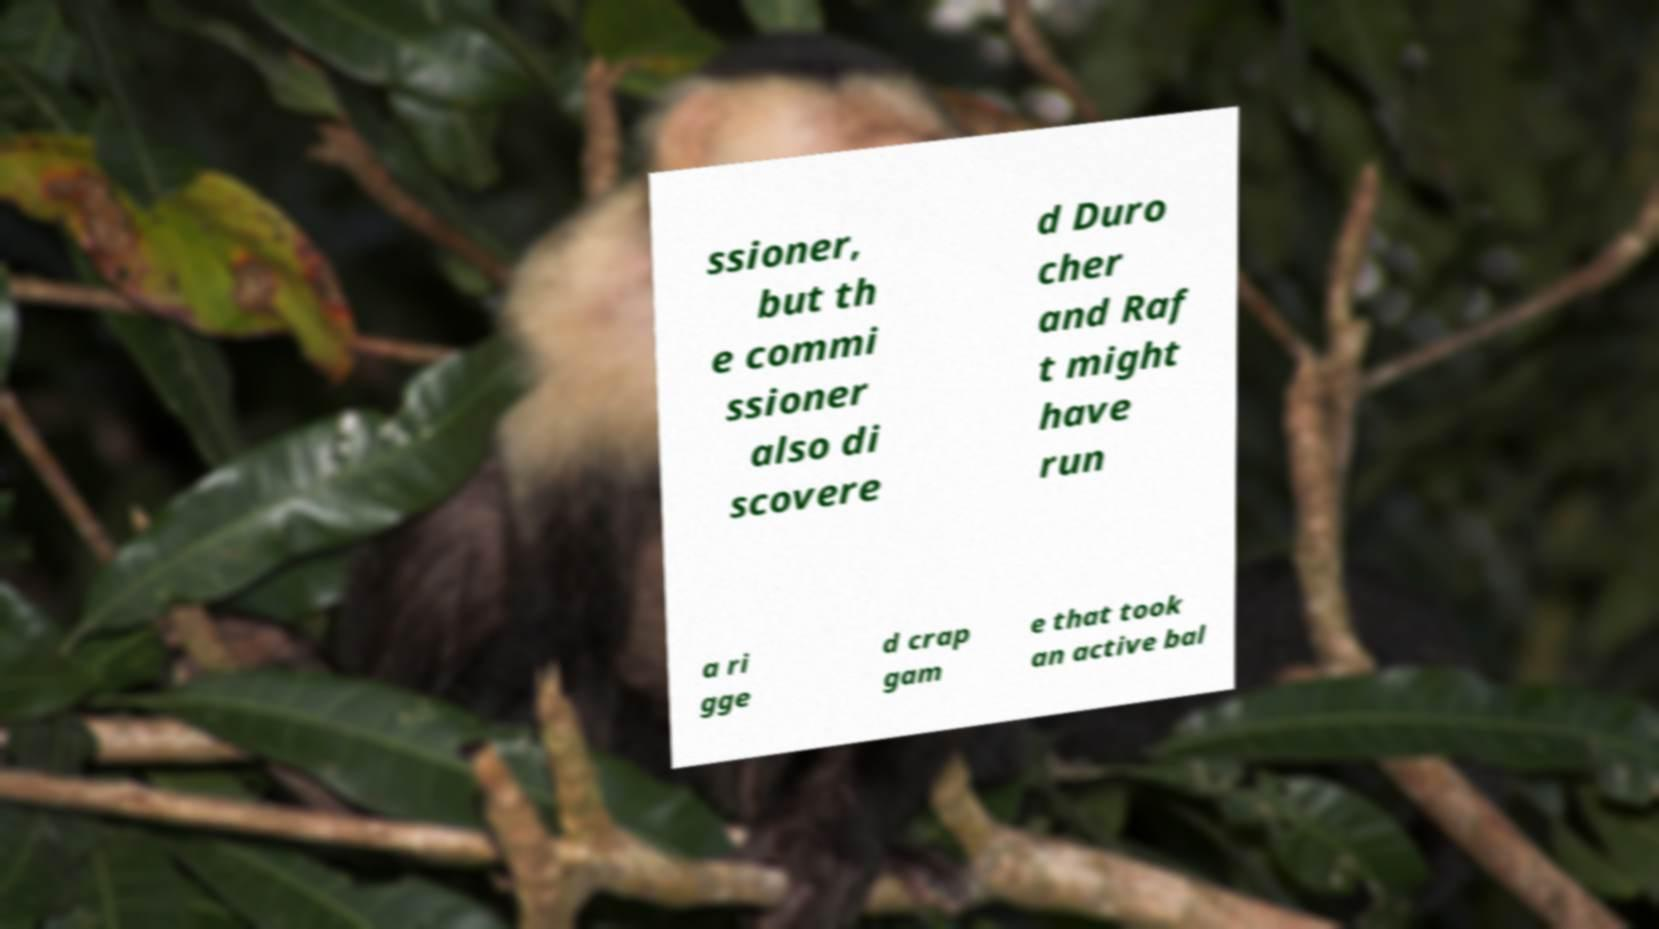Could you extract and type out the text from this image? ssioner, but th e commi ssioner also di scovere d Duro cher and Raf t might have run a ri gge d crap gam e that took an active bal 